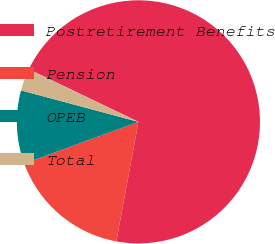Convert chart. <chart><loc_0><loc_0><loc_500><loc_500><pie_chart><fcel>Postretirement Benefits<fcel>Pension<fcel>OPEB<fcel>Total<nl><fcel>70.78%<fcel>16.52%<fcel>9.74%<fcel>2.96%<nl></chart> 